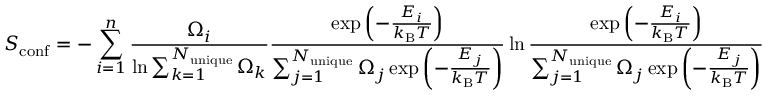<formula> <loc_0><loc_0><loc_500><loc_500>S _ { c o n f } = - \sum _ { i = 1 } ^ { n } \frac { \Omega _ { i } } { \ln { \sum _ { k = 1 } ^ { N _ { u n i q u e } } \Omega _ { k } } } \frac { \exp { \left ( - \frac { E _ { i } } { k _ { B } T } \right ) } } { \sum _ { j = 1 } ^ { N _ { u n i q u e } } \Omega _ { j } \exp { \left ( - \frac { E _ { j } } { k _ { B } T } \right ) } } \ln { \frac { \exp { \left ( - \frac { E _ { i } } { k _ { B } T } \right ) } } { \sum _ { j = 1 } ^ { N _ { u n i q u e } } \Omega _ { j } \exp { \left ( - \frac { E _ { j } } { k _ { B } T } \right ) } } }</formula> 